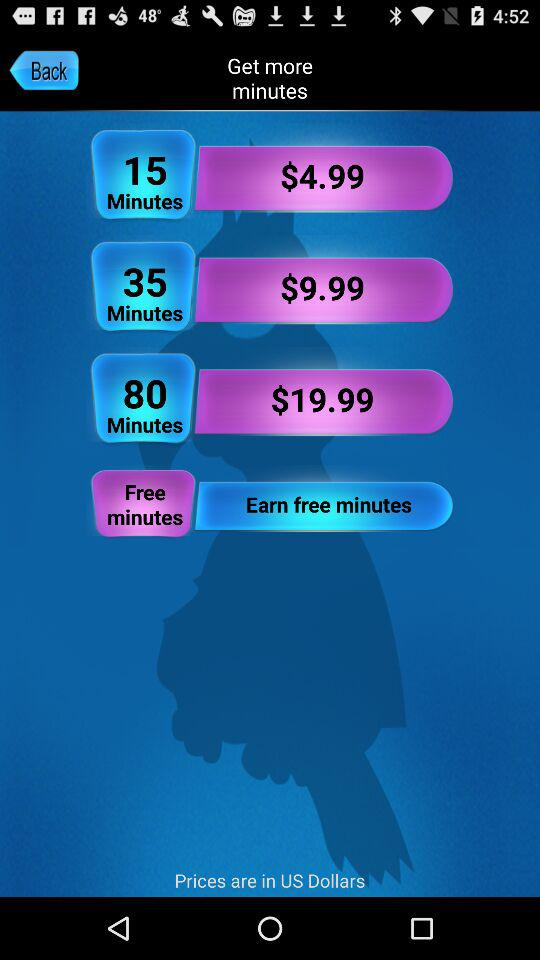How many minutes do you get for 9.99 dollars? You get 35 minutes for 9.99 dollars. 